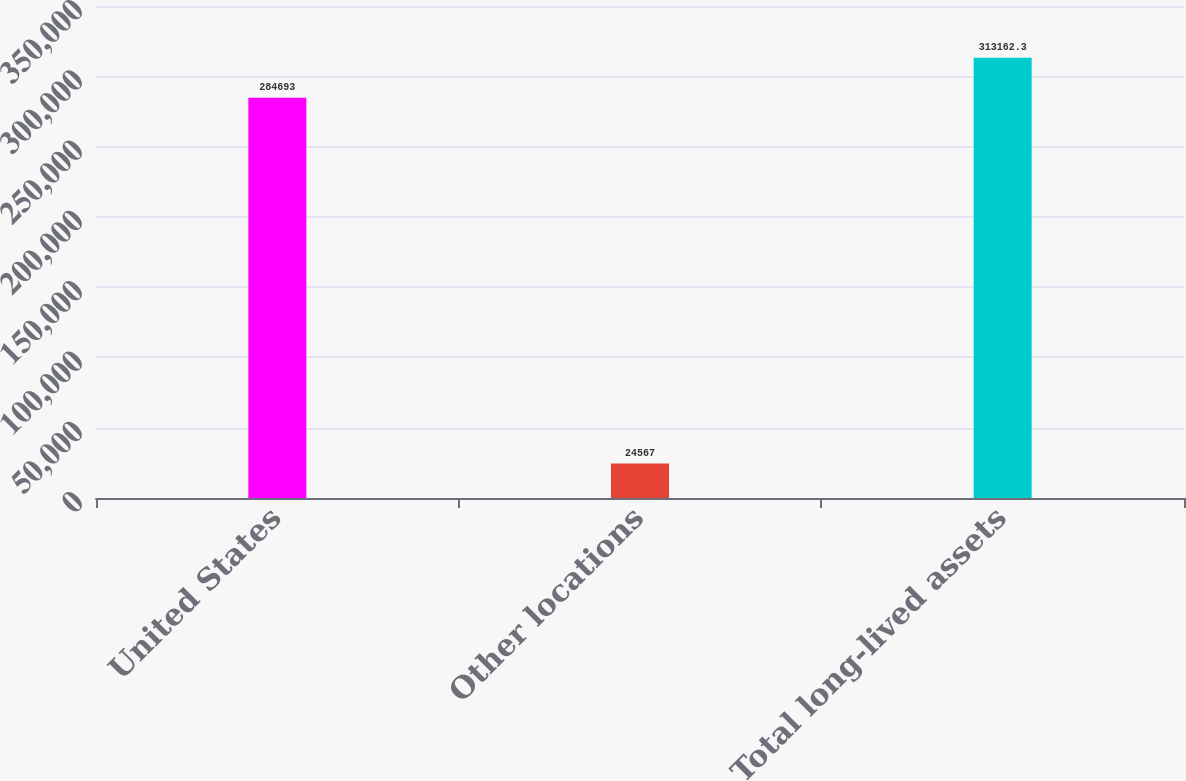<chart> <loc_0><loc_0><loc_500><loc_500><bar_chart><fcel>United States<fcel>Other locations<fcel>Total long-lived assets<nl><fcel>284693<fcel>24567<fcel>313162<nl></chart> 